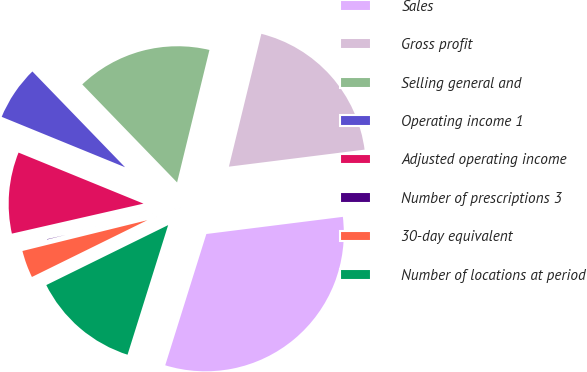Convert chart. <chart><loc_0><loc_0><loc_500><loc_500><pie_chart><fcel>Sales<fcel>Gross profit<fcel>Selling general and<fcel>Operating income 1<fcel>Adjusted operating income<fcel>Number of prescriptions 3<fcel>30-day equivalent<fcel>Number of locations at period<nl><fcel>31.82%<fcel>19.2%<fcel>16.05%<fcel>6.59%<fcel>9.74%<fcel>0.28%<fcel>3.43%<fcel>12.89%<nl></chart> 